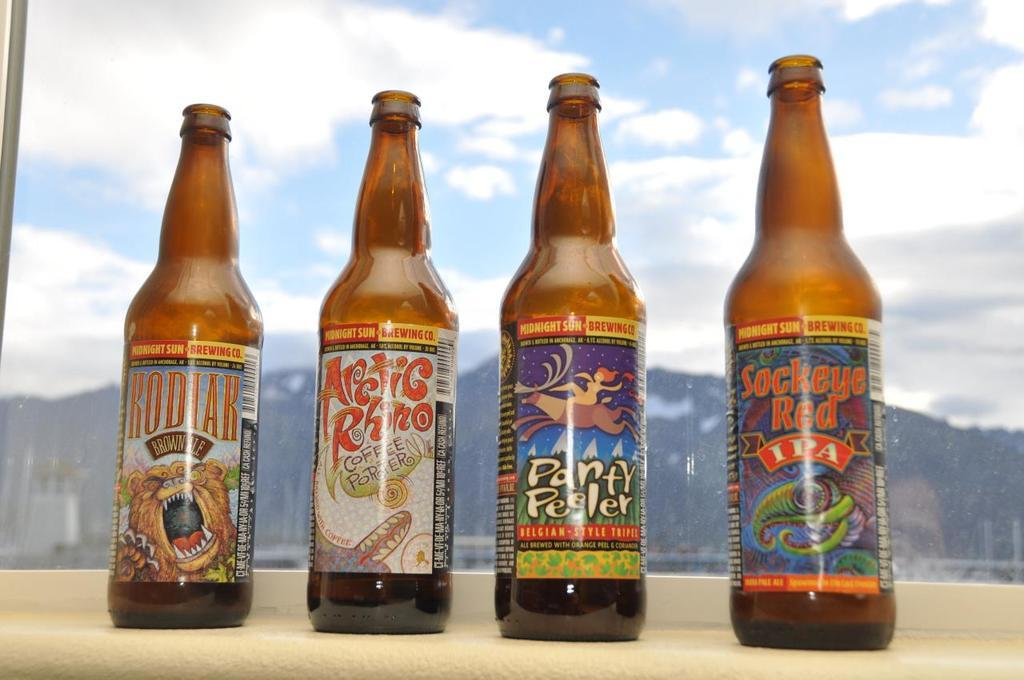<image>
Share a concise interpretation of the image provided. Four beer bottles are lined up on a windowsill and one is called Arctic Rhino. 